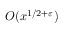<formula> <loc_0><loc_0><loc_500><loc_500>O ( x ^ { 1 / 2 + \varepsilon } )</formula> 